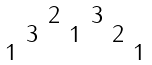Convert formula to latex. <formula><loc_0><loc_0><loc_500><loc_500>\begin{smallmatrix} & & 2 & & 3 \\ & 3 & & 1 & & 2 \\ 1 & & & & & & 1 \end{smallmatrix}</formula> 